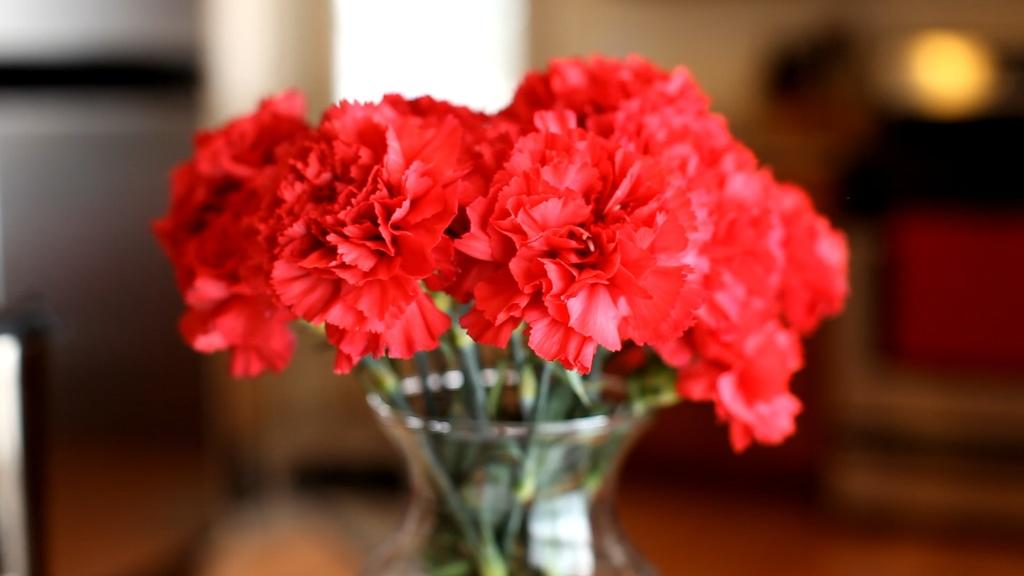What is located in the foreground of the image? There are flowers in a glass pot in the foreground of the image. What can be seen in the background of the image? There are objects, a couch, a pillow, and other unspecified objects in the background of the image. Can you describe the lighting in the image? There is light visible in the image. What type of jelly is being used to hold the flowers in the glass pot? There is no jelly present in the image; the flowers are in a glass pot. What theory is being discussed by the objects in the background of the image? There is no discussion or theory present in the image; it features flowers in a glass pot and objects in the background. 